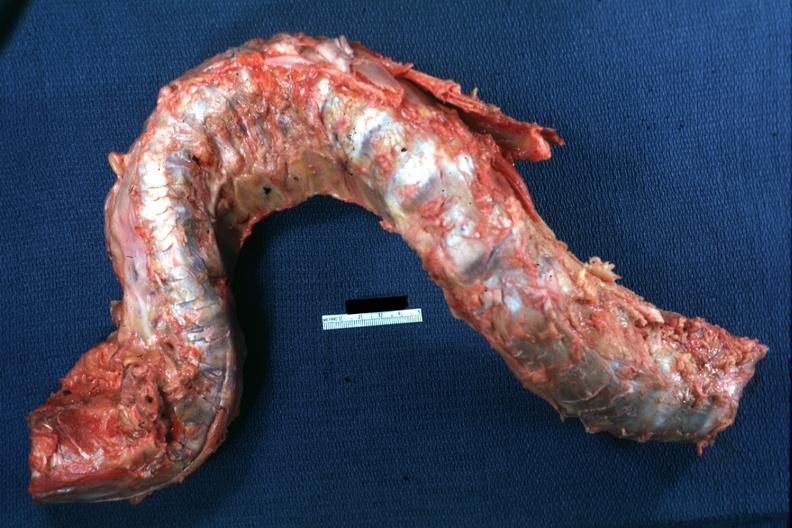does this protocol show excised spinal column grossly deformed?
Answer the question using a single word or phrase. No 